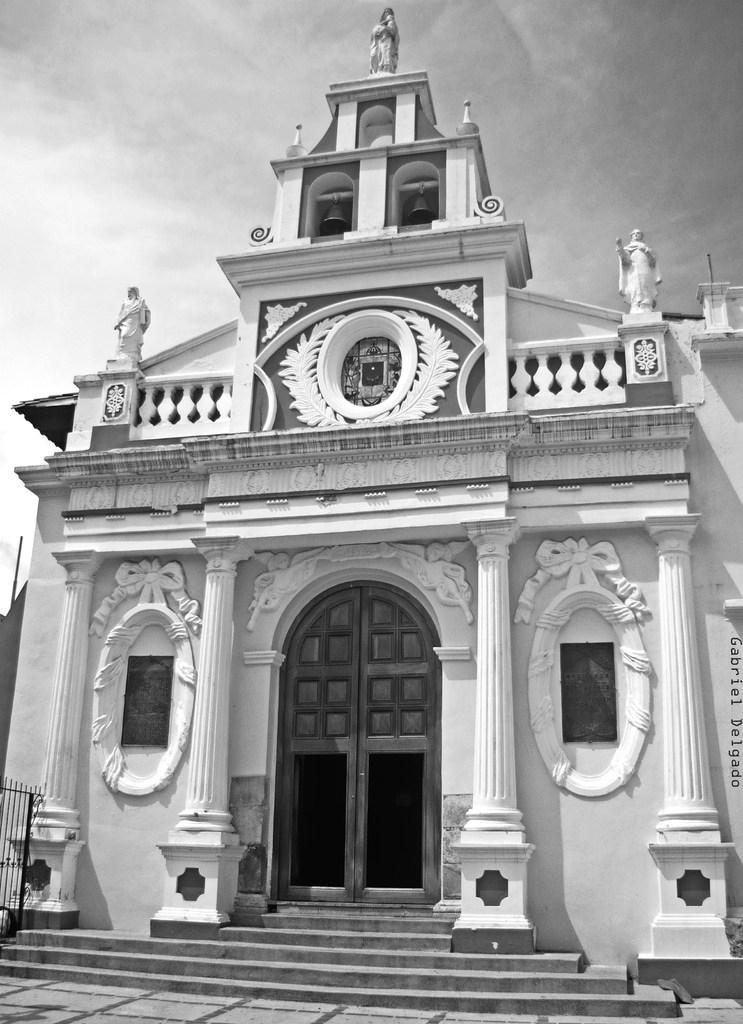What type of structure is visible in the image? There is a building in the image. What artistic elements can be seen in the image? There are sculptures in the image. Where is the text located in the image? The text is on the right side of the image. What color scheme is used in the image? The image is in black and white. How many toys can be seen in the image? There are no toys present in the image. 